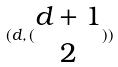Convert formula to latex. <formula><loc_0><loc_0><loc_500><loc_500>( d , ( \begin{matrix} d + 1 \\ 2 \end{matrix} ) )</formula> 